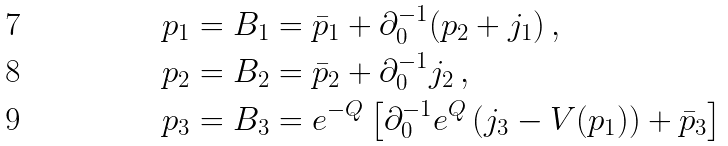<formula> <loc_0><loc_0><loc_500><loc_500>p _ { 1 } & = B _ { 1 } = \bar { p } _ { 1 } + \partial _ { 0 } ^ { - 1 } ( p _ { 2 } + j _ { 1 } ) \, , \\ p _ { 2 } & = B _ { 2 } = \bar { p } _ { 2 } + \partial _ { 0 } ^ { - 1 } j _ { 2 } \, , \\ p _ { 3 } & = B _ { 3 } = e ^ { - Q } \left [ \partial _ { 0 } ^ { - 1 } e ^ { Q } \left ( j _ { 3 } - V ( p _ { 1 } ) \right ) + \bar { p } _ { 3 } \right ]</formula> 